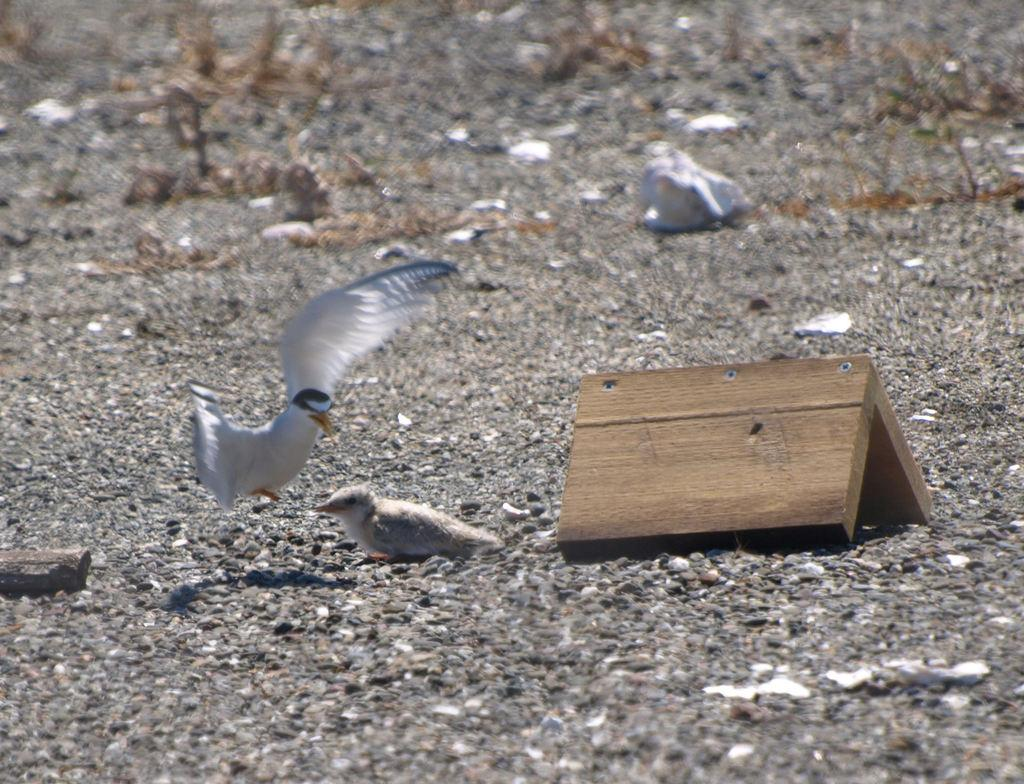What type of animals can be seen in the image? There are birds in the image. What is visible beneath the birds? The ground is visible in the image. Can you describe any objects made of wood in the image? There is a wooden object in the image. What type of birthday celebration is taking place in the image? There is no indication of a birthday celebration in the image. What punishment is being administered to the birds in the image? There is no punishment being administered to the birds in the image. 